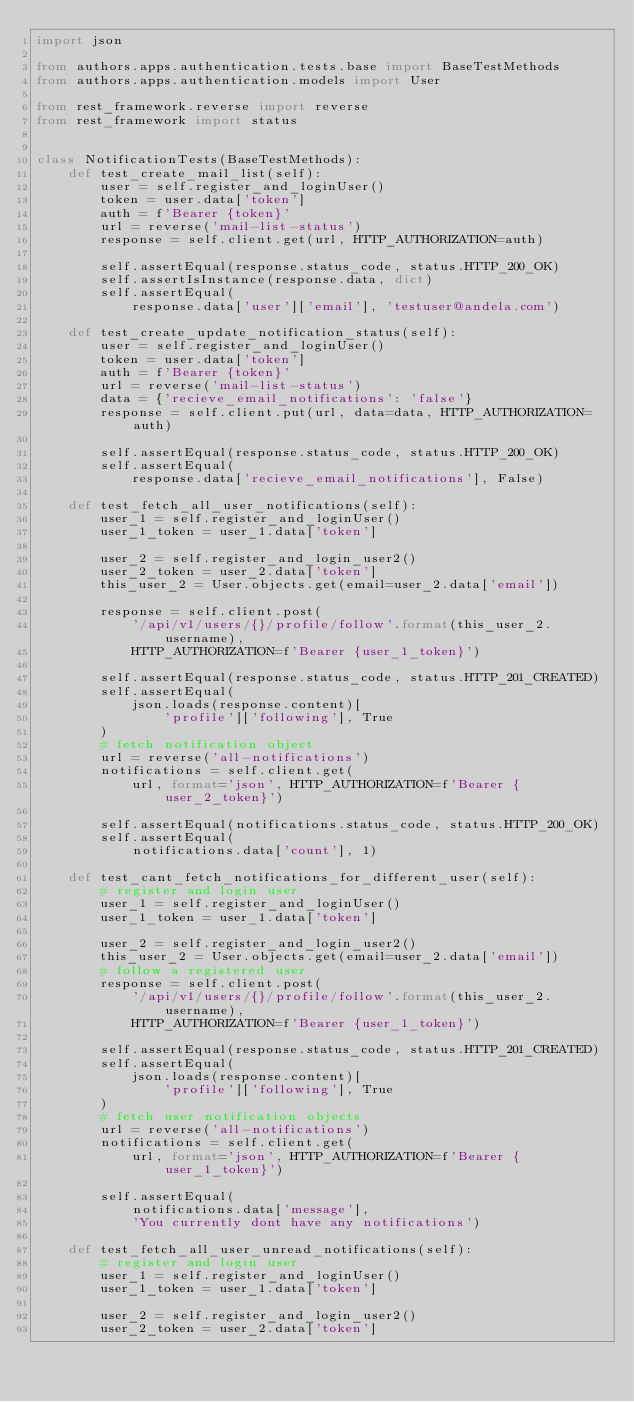Convert code to text. <code><loc_0><loc_0><loc_500><loc_500><_Python_>import json

from authors.apps.authentication.tests.base import BaseTestMethods
from authors.apps.authentication.models import User

from rest_framework.reverse import reverse
from rest_framework import status


class NotificationTests(BaseTestMethods):
    def test_create_mail_list(self):
        user = self.register_and_loginUser()
        token = user.data['token']
        auth = f'Bearer {token}'
        url = reverse('mail-list-status')
        response = self.client.get(url, HTTP_AUTHORIZATION=auth)

        self.assertEqual(response.status_code, status.HTTP_200_OK)
        self.assertIsInstance(response.data, dict)
        self.assertEqual(
            response.data['user']['email'], 'testuser@andela.com')

    def test_create_update_notification_status(self):
        user = self.register_and_loginUser()
        token = user.data['token']
        auth = f'Bearer {token}'
        url = reverse('mail-list-status')
        data = {'recieve_email_notifications': 'false'}
        response = self.client.put(url, data=data, HTTP_AUTHORIZATION=auth)

        self.assertEqual(response.status_code, status.HTTP_200_OK)
        self.assertEqual(
            response.data['recieve_email_notifications'], False)

    def test_fetch_all_user_notifications(self):
        user_1 = self.register_and_loginUser()
        user_1_token = user_1.data['token']

        user_2 = self.register_and_login_user2()
        user_2_token = user_2.data['token']
        this_user_2 = User.objects.get(email=user_2.data['email'])

        response = self.client.post(
            '/api/v1/users/{}/profile/follow'.format(this_user_2.username),
            HTTP_AUTHORIZATION=f'Bearer {user_1_token}')

        self.assertEqual(response.status_code, status.HTTP_201_CREATED)
        self.assertEqual(
            json.loads(response.content)[
                'profile']['following'], True
        )
        # fetch notification object
        url = reverse('all-notifications')
        notifications = self.client.get(
            url, format='json', HTTP_AUTHORIZATION=f'Bearer {user_2_token}')

        self.assertEqual(notifications.status_code, status.HTTP_200_OK)
        self.assertEqual(
            notifications.data['count'], 1)

    def test_cant_fetch_notifications_for_different_user(self):
        # register and login user
        user_1 = self.register_and_loginUser()
        user_1_token = user_1.data['token']

        user_2 = self.register_and_login_user2()
        this_user_2 = User.objects.get(email=user_2.data['email'])
        # follow a registered user
        response = self.client.post(
            '/api/v1/users/{}/profile/follow'.format(this_user_2.username),
            HTTP_AUTHORIZATION=f'Bearer {user_1_token}')

        self.assertEqual(response.status_code, status.HTTP_201_CREATED)
        self.assertEqual(
            json.loads(response.content)[
                'profile']['following'], True
        )
        # fetch user notification objects
        url = reverse('all-notifications')
        notifications = self.client.get(
            url, format='json', HTTP_AUTHORIZATION=f'Bearer {user_1_token}')

        self.assertEqual(
            notifications.data['message'],
            'You currently dont have any notifications')

    def test_fetch_all_user_unread_notifications(self):
        # register and login user
        user_1 = self.register_and_loginUser()
        user_1_token = user_1.data['token']

        user_2 = self.register_and_login_user2()
        user_2_token = user_2.data['token']</code> 